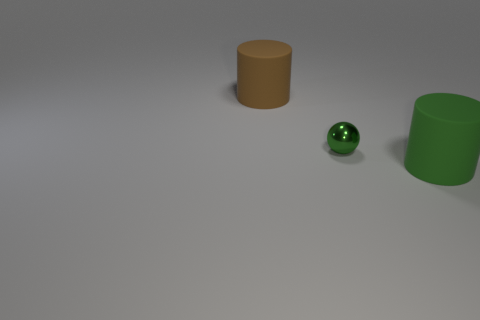How many objects are either big objects or rubber cylinders behind the green matte cylinder?
Your response must be concise. 2. What number of big matte cylinders are behind the matte cylinder in front of the large matte cylinder left of the small green object?
Provide a succinct answer. 1. What material is the other thing that is the same color as the tiny object?
Keep it short and to the point. Rubber. How many large blue shiny cubes are there?
Your response must be concise. 0. There is a thing that is to the left of the green sphere; does it have the same size as the big green matte object?
Offer a very short reply. Yes. How many metallic objects are small green things or large brown objects?
Your response must be concise. 1. There is a big cylinder that is behind the large green object; what number of small green shiny spheres are to the left of it?
Provide a short and direct response. 0. What shape is the object that is both to the right of the brown matte cylinder and on the left side of the big green thing?
Offer a terse response. Sphere. What material is the big cylinder that is in front of the cylinder behind the big object to the right of the tiny green metal ball?
Offer a terse response. Rubber. What is the size of the rubber object that is the same color as the ball?
Your answer should be very brief. Large. 